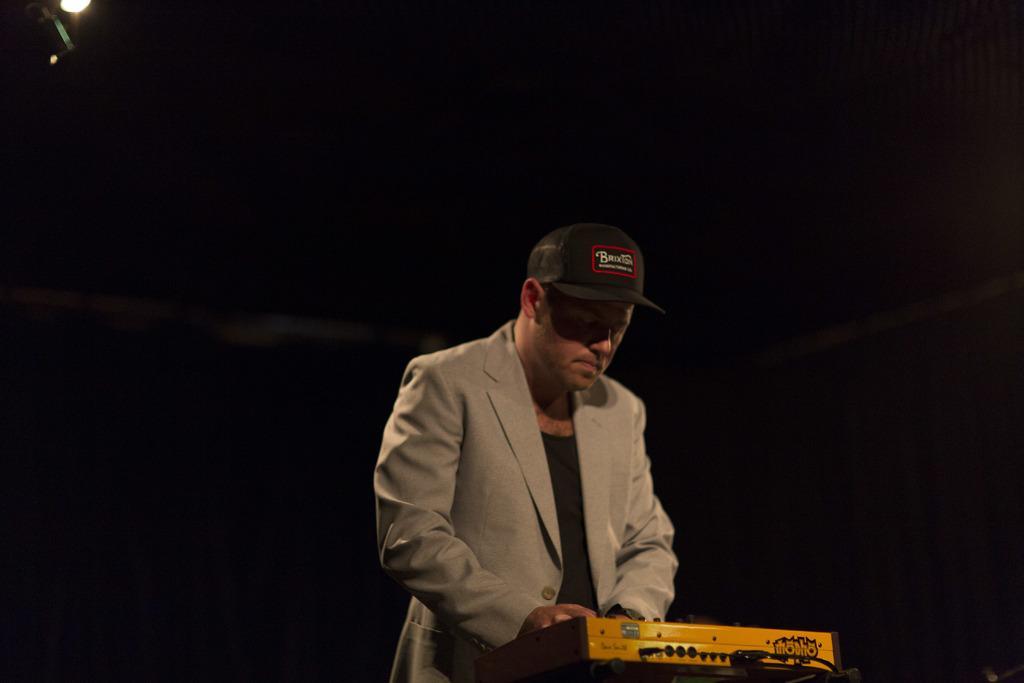Describe this image in one or two sentences. In this image I can see the person standing and wearing the ash and black aldo dress and also cap. He is standing in-front of the musical instrument and there is a black background. I can also see the light in the top. 